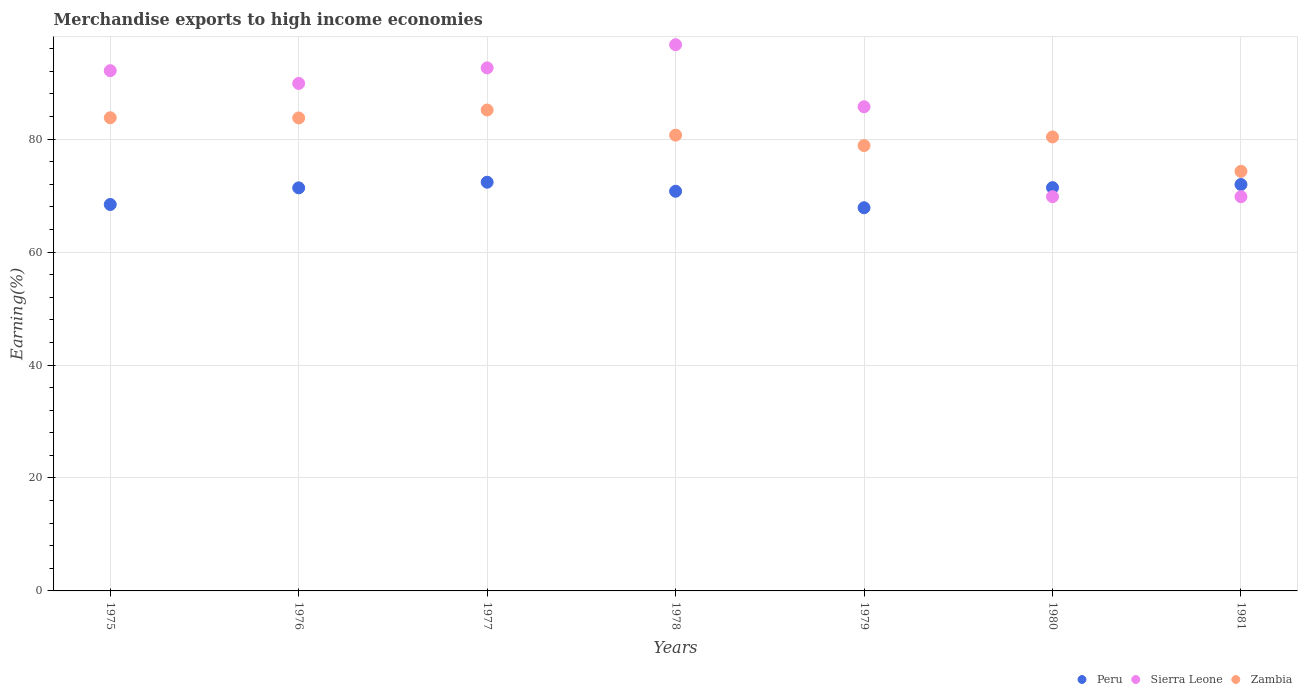How many different coloured dotlines are there?
Keep it short and to the point. 3. Is the number of dotlines equal to the number of legend labels?
Make the answer very short. Yes. What is the percentage of amount earned from merchandise exports in Peru in 1976?
Your answer should be compact. 71.38. Across all years, what is the maximum percentage of amount earned from merchandise exports in Sierra Leone?
Offer a very short reply. 96.72. Across all years, what is the minimum percentage of amount earned from merchandise exports in Zambia?
Provide a succinct answer. 74.3. In which year was the percentage of amount earned from merchandise exports in Peru maximum?
Give a very brief answer. 1977. In which year was the percentage of amount earned from merchandise exports in Sierra Leone minimum?
Keep it short and to the point. 1980. What is the total percentage of amount earned from merchandise exports in Sierra Leone in the graph?
Provide a short and direct response. 596.7. What is the difference between the percentage of amount earned from merchandise exports in Zambia in 1976 and that in 1978?
Give a very brief answer. 3.04. What is the difference between the percentage of amount earned from merchandise exports in Zambia in 1979 and the percentage of amount earned from merchandise exports in Sierra Leone in 1978?
Make the answer very short. -17.86. What is the average percentage of amount earned from merchandise exports in Zambia per year?
Offer a terse response. 81. In the year 1978, what is the difference between the percentage of amount earned from merchandise exports in Peru and percentage of amount earned from merchandise exports in Zambia?
Make the answer very short. -9.94. What is the ratio of the percentage of amount earned from merchandise exports in Sierra Leone in 1978 to that in 1981?
Keep it short and to the point. 1.39. What is the difference between the highest and the second highest percentage of amount earned from merchandise exports in Sierra Leone?
Offer a very short reply. 4.1. What is the difference between the highest and the lowest percentage of amount earned from merchandise exports in Peru?
Your answer should be compact. 4.52. Does the percentage of amount earned from merchandise exports in Sierra Leone monotonically increase over the years?
Ensure brevity in your answer.  No. Is the percentage of amount earned from merchandise exports in Peru strictly less than the percentage of amount earned from merchandise exports in Zambia over the years?
Ensure brevity in your answer.  Yes. How many dotlines are there?
Offer a very short reply. 3. How many years are there in the graph?
Offer a very short reply. 7. Does the graph contain any zero values?
Offer a very short reply. No. Does the graph contain grids?
Your answer should be very brief. Yes. Where does the legend appear in the graph?
Offer a very short reply. Bottom right. How many legend labels are there?
Your response must be concise. 3. What is the title of the graph?
Offer a terse response. Merchandise exports to high income economies. What is the label or title of the X-axis?
Give a very brief answer. Years. What is the label or title of the Y-axis?
Your answer should be very brief. Earning(%). What is the Earning(%) in Peru in 1975?
Offer a terse response. 68.43. What is the Earning(%) in Sierra Leone in 1975?
Your response must be concise. 92.13. What is the Earning(%) in Zambia in 1975?
Keep it short and to the point. 83.79. What is the Earning(%) in Peru in 1976?
Give a very brief answer. 71.38. What is the Earning(%) of Sierra Leone in 1976?
Your answer should be compact. 89.87. What is the Earning(%) in Zambia in 1976?
Keep it short and to the point. 83.76. What is the Earning(%) in Peru in 1977?
Offer a terse response. 72.38. What is the Earning(%) in Sierra Leone in 1977?
Provide a short and direct response. 92.62. What is the Earning(%) in Zambia in 1977?
Give a very brief answer. 85.16. What is the Earning(%) of Peru in 1978?
Offer a very short reply. 70.78. What is the Earning(%) of Sierra Leone in 1978?
Keep it short and to the point. 96.72. What is the Earning(%) in Zambia in 1978?
Offer a very short reply. 80.71. What is the Earning(%) in Peru in 1979?
Keep it short and to the point. 67.86. What is the Earning(%) of Sierra Leone in 1979?
Provide a succinct answer. 85.74. What is the Earning(%) in Zambia in 1979?
Your response must be concise. 78.87. What is the Earning(%) in Peru in 1980?
Your answer should be very brief. 71.42. What is the Earning(%) in Sierra Leone in 1980?
Make the answer very short. 69.81. What is the Earning(%) of Zambia in 1980?
Your answer should be very brief. 80.39. What is the Earning(%) of Peru in 1981?
Make the answer very short. 71.97. What is the Earning(%) of Sierra Leone in 1981?
Ensure brevity in your answer.  69.81. What is the Earning(%) of Zambia in 1981?
Keep it short and to the point. 74.3. Across all years, what is the maximum Earning(%) in Peru?
Your answer should be very brief. 72.38. Across all years, what is the maximum Earning(%) in Sierra Leone?
Offer a very short reply. 96.72. Across all years, what is the maximum Earning(%) in Zambia?
Ensure brevity in your answer.  85.16. Across all years, what is the minimum Earning(%) of Peru?
Give a very brief answer. 67.86. Across all years, what is the minimum Earning(%) in Sierra Leone?
Ensure brevity in your answer.  69.81. Across all years, what is the minimum Earning(%) of Zambia?
Your answer should be compact. 74.3. What is the total Earning(%) in Peru in the graph?
Your answer should be very brief. 494.2. What is the total Earning(%) of Sierra Leone in the graph?
Keep it short and to the point. 596.7. What is the total Earning(%) in Zambia in the graph?
Ensure brevity in your answer.  566.99. What is the difference between the Earning(%) in Peru in 1975 and that in 1976?
Your answer should be very brief. -2.95. What is the difference between the Earning(%) in Sierra Leone in 1975 and that in 1976?
Your answer should be compact. 2.26. What is the difference between the Earning(%) of Zambia in 1975 and that in 1976?
Give a very brief answer. 0.03. What is the difference between the Earning(%) in Peru in 1975 and that in 1977?
Offer a terse response. -3.95. What is the difference between the Earning(%) of Sierra Leone in 1975 and that in 1977?
Keep it short and to the point. -0.5. What is the difference between the Earning(%) in Zambia in 1975 and that in 1977?
Your response must be concise. -1.37. What is the difference between the Earning(%) of Peru in 1975 and that in 1978?
Make the answer very short. -2.35. What is the difference between the Earning(%) of Sierra Leone in 1975 and that in 1978?
Offer a very short reply. -4.6. What is the difference between the Earning(%) of Zambia in 1975 and that in 1978?
Ensure brevity in your answer.  3.08. What is the difference between the Earning(%) in Peru in 1975 and that in 1979?
Your answer should be very brief. 0.57. What is the difference between the Earning(%) in Sierra Leone in 1975 and that in 1979?
Make the answer very short. 6.39. What is the difference between the Earning(%) of Zambia in 1975 and that in 1979?
Offer a terse response. 4.92. What is the difference between the Earning(%) in Peru in 1975 and that in 1980?
Your response must be concise. -2.99. What is the difference between the Earning(%) in Sierra Leone in 1975 and that in 1980?
Your answer should be compact. 22.32. What is the difference between the Earning(%) of Zambia in 1975 and that in 1980?
Make the answer very short. 3.4. What is the difference between the Earning(%) in Peru in 1975 and that in 1981?
Provide a short and direct response. -3.54. What is the difference between the Earning(%) in Sierra Leone in 1975 and that in 1981?
Offer a very short reply. 22.32. What is the difference between the Earning(%) of Zambia in 1975 and that in 1981?
Your answer should be very brief. 9.49. What is the difference between the Earning(%) of Peru in 1976 and that in 1977?
Offer a very short reply. -1. What is the difference between the Earning(%) of Sierra Leone in 1976 and that in 1977?
Provide a short and direct response. -2.76. What is the difference between the Earning(%) in Zambia in 1976 and that in 1977?
Provide a succinct answer. -1.4. What is the difference between the Earning(%) in Peru in 1976 and that in 1978?
Make the answer very short. 0.6. What is the difference between the Earning(%) in Sierra Leone in 1976 and that in 1978?
Give a very brief answer. -6.86. What is the difference between the Earning(%) in Zambia in 1976 and that in 1978?
Make the answer very short. 3.04. What is the difference between the Earning(%) in Peru in 1976 and that in 1979?
Give a very brief answer. 3.52. What is the difference between the Earning(%) in Sierra Leone in 1976 and that in 1979?
Your answer should be compact. 4.13. What is the difference between the Earning(%) in Zambia in 1976 and that in 1979?
Ensure brevity in your answer.  4.89. What is the difference between the Earning(%) of Peru in 1976 and that in 1980?
Your response must be concise. -0.04. What is the difference between the Earning(%) in Sierra Leone in 1976 and that in 1980?
Keep it short and to the point. 20.06. What is the difference between the Earning(%) of Zambia in 1976 and that in 1980?
Provide a short and direct response. 3.37. What is the difference between the Earning(%) in Peru in 1976 and that in 1981?
Your answer should be compact. -0.59. What is the difference between the Earning(%) of Sierra Leone in 1976 and that in 1981?
Make the answer very short. 20.06. What is the difference between the Earning(%) in Zambia in 1976 and that in 1981?
Make the answer very short. 9.45. What is the difference between the Earning(%) of Peru in 1977 and that in 1978?
Provide a short and direct response. 1.6. What is the difference between the Earning(%) in Sierra Leone in 1977 and that in 1978?
Offer a very short reply. -4.1. What is the difference between the Earning(%) in Zambia in 1977 and that in 1978?
Your answer should be compact. 4.45. What is the difference between the Earning(%) in Peru in 1977 and that in 1979?
Ensure brevity in your answer.  4.52. What is the difference between the Earning(%) in Sierra Leone in 1977 and that in 1979?
Offer a very short reply. 6.89. What is the difference between the Earning(%) of Zambia in 1977 and that in 1979?
Provide a succinct answer. 6.29. What is the difference between the Earning(%) in Sierra Leone in 1977 and that in 1980?
Your answer should be compact. 22.81. What is the difference between the Earning(%) in Zambia in 1977 and that in 1980?
Your answer should be compact. 4.77. What is the difference between the Earning(%) of Peru in 1977 and that in 1981?
Ensure brevity in your answer.  0.41. What is the difference between the Earning(%) of Sierra Leone in 1977 and that in 1981?
Make the answer very short. 22.81. What is the difference between the Earning(%) of Zambia in 1977 and that in 1981?
Make the answer very short. 10.86. What is the difference between the Earning(%) in Peru in 1978 and that in 1979?
Offer a very short reply. 2.92. What is the difference between the Earning(%) in Sierra Leone in 1978 and that in 1979?
Offer a very short reply. 10.99. What is the difference between the Earning(%) in Zambia in 1978 and that in 1979?
Offer a very short reply. 1.85. What is the difference between the Earning(%) in Peru in 1978 and that in 1980?
Your answer should be very brief. -0.64. What is the difference between the Earning(%) in Sierra Leone in 1978 and that in 1980?
Keep it short and to the point. 26.91. What is the difference between the Earning(%) in Zambia in 1978 and that in 1980?
Your response must be concise. 0.32. What is the difference between the Earning(%) in Peru in 1978 and that in 1981?
Give a very brief answer. -1.19. What is the difference between the Earning(%) of Sierra Leone in 1978 and that in 1981?
Ensure brevity in your answer.  26.91. What is the difference between the Earning(%) of Zambia in 1978 and that in 1981?
Offer a terse response. 6.41. What is the difference between the Earning(%) of Peru in 1979 and that in 1980?
Your answer should be compact. -3.56. What is the difference between the Earning(%) in Sierra Leone in 1979 and that in 1980?
Ensure brevity in your answer.  15.93. What is the difference between the Earning(%) of Zambia in 1979 and that in 1980?
Give a very brief answer. -1.52. What is the difference between the Earning(%) of Peru in 1979 and that in 1981?
Your answer should be very brief. -4.11. What is the difference between the Earning(%) of Sierra Leone in 1979 and that in 1981?
Offer a terse response. 15.93. What is the difference between the Earning(%) in Zambia in 1979 and that in 1981?
Offer a terse response. 4.56. What is the difference between the Earning(%) in Peru in 1980 and that in 1981?
Give a very brief answer. -0.55. What is the difference between the Earning(%) in Sierra Leone in 1980 and that in 1981?
Ensure brevity in your answer.  -0. What is the difference between the Earning(%) in Zambia in 1980 and that in 1981?
Provide a succinct answer. 6.09. What is the difference between the Earning(%) in Peru in 1975 and the Earning(%) in Sierra Leone in 1976?
Give a very brief answer. -21.44. What is the difference between the Earning(%) in Peru in 1975 and the Earning(%) in Zambia in 1976?
Keep it short and to the point. -15.33. What is the difference between the Earning(%) of Sierra Leone in 1975 and the Earning(%) of Zambia in 1976?
Keep it short and to the point. 8.37. What is the difference between the Earning(%) of Peru in 1975 and the Earning(%) of Sierra Leone in 1977?
Make the answer very short. -24.19. What is the difference between the Earning(%) of Peru in 1975 and the Earning(%) of Zambia in 1977?
Your response must be concise. -16.73. What is the difference between the Earning(%) in Sierra Leone in 1975 and the Earning(%) in Zambia in 1977?
Your answer should be very brief. 6.97. What is the difference between the Earning(%) in Peru in 1975 and the Earning(%) in Sierra Leone in 1978?
Offer a very short reply. -28.29. What is the difference between the Earning(%) of Peru in 1975 and the Earning(%) of Zambia in 1978?
Offer a very short reply. -12.28. What is the difference between the Earning(%) of Sierra Leone in 1975 and the Earning(%) of Zambia in 1978?
Provide a short and direct response. 11.41. What is the difference between the Earning(%) of Peru in 1975 and the Earning(%) of Sierra Leone in 1979?
Your answer should be very brief. -17.31. What is the difference between the Earning(%) of Peru in 1975 and the Earning(%) of Zambia in 1979?
Ensure brevity in your answer.  -10.44. What is the difference between the Earning(%) in Sierra Leone in 1975 and the Earning(%) in Zambia in 1979?
Keep it short and to the point. 13.26. What is the difference between the Earning(%) in Peru in 1975 and the Earning(%) in Sierra Leone in 1980?
Offer a terse response. -1.38. What is the difference between the Earning(%) of Peru in 1975 and the Earning(%) of Zambia in 1980?
Your answer should be very brief. -11.96. What is the difference between the Earning(%) in Sierra Leone in 1975 and the Earning(%) in Zambia in 1980?
Provide a short and direct response. 11.74. What is the difference between the Earning(%) of Peru in 1975 and the Earning(%) of Sierra Leone in 1981?
Your response must be concise. -1.38. What is the difference between the Earning(%) of Peru in 1975 and the Earning(%) of Zambia in 1981?
Your answer should be very brief. -5.87. What is the difference between the Earning(%) of Sierra Leone in 1975 and the Earning(%) of Zambia in 1981?
Provide a short and direct response. 17.82. What is the difference between the Earning(%) of Peru in 1976 and the Earning(%) of Sierra Leone in 1977?
Offer a terse response. -21.25. What is the difference between the Earning(%) in Peru in 1976 and the Earning(%) in Zambia in 1977?
Your answer should be very brief. -13.79. What is the difference between the Earning(%) of Sierra Leone in 1976 and the Earning(%) of Zambia in 1977?
Give a very brief answer. 4.71. What is the difference between the Earning(%) in Peru in 1976 and the Earning(%) in Sierra Leone in 1978?
Provide a short and direct response. -25.35. What is the difference between the Earning(%) of Peru in 1976 and the Earning(%) of Zambia in 1978?
Keep it short and to the point. -9.34. What is the difference between the Earning(%) in Sierra Leone in 1976 and the Earning(%) in Zambia in 1978?
Provide a short and direct response. 9.15. What is the difference between the Earning(%) of Peru in 1976 and the Earning(%) of Sierra Leone in 1979?
Ensure brevity in your answer.  -14.36. What is the difference between the Earning(%) in Peru in 1976 and the Earning(%) in Zambia in 1979?
Your answer should be very brief. -7.49. What is the difference between the Earning(%) of Sierra Leone in 1976 and the Earning(%) of Zambia in 1979?
Your answer should be compact. 11. What is the difference between the Earning(%) in Peru in 1976 and the Earning(%) in Sierra Leone in 1980?
Offer a very short reply. 1.56. What is the difference between the Earning(%) of Peru in 1976 and the Earning(%) of Zambia in 1980?
Provide a succinct answer. -9.02. What is the difference between the Earning(%) of Sierra Leone in 1976 and the Earning(%) of Zambia in 1980?
Your answer should be compact. 9.48. What is the difference between the Earning(%) of Peru in 1976 and the Earning(%) of Sierra Leone in 1981?
Your answer should be very brief. 1.56. What is the difference between the Earning(%) of Peru in 1976 and the Earning(%) of Zambia in 1981?
Your response must be concise. -2.93. What is the difference between the Earning(%) of Sierra Leone in 1976 and the Earning(%) of Zambia in 1981?
Your answer should be very brief. 15.56. What is the difference between the Earning(%) of Peru in 1977 and the Earning(%) of Sierra Leone in 1978?
Your response must be concise. -24.35. What is the difference between the Earning(%) of Peru in 1977 and the Earning(%) of Zambia in 1978?
Keep it short and to the point. -8.34. What is the difference between the Earning(%) in Sierra Leone in 1977 and the Earning(%) in Zambia in 1978?
Keep it short and to the point. 11.91. What is the difference between the Earning(%) of Peru in 1977 and the Earning(%) of Sierra Leone in 1979?
Provide a succinct answer. -13.36. What is the difference between the Earning(%) in Peru in 1977 and the Earning(%) in Zambia in 1979?
Provide a short and direct response. -6.49. What is the difference between the Earning(%) in Sierra Leone in 1977 and the Earning(%) in Zambia in 1979?
Offer a terse response. 13.76. What is the difference between the Earning(%) in Peru in 1977 and the Earning(%) in Sierra Leone in 1980?
Make the answer very short. 2.57. What is the difference between the Earning(%) in Peru in 1977 and the Earning(%) in Zambia in 1980?
Provide a short and direct response. -8.02. What is the difference between the Earning(%) in Sierra Leone in 1977 and the Earning(%) in Zambia in 1980?
Give a very brief answer. 12.23. What is the difference between the Earning(%) in Peru in 1977 and the Earning(%) in Sierra Leone in 1981?
Your response must be concise. 2.57. What is the difference between the Earning(%) of Peru in 1977 and the Earning(%) of Zambia in 1981?
Your answer should be very brief. -1.93. What is the difference between the Earning(%) of Sierra Leone in 1977 and the Earning(%) of Zambia in 1981?
Your answer should be very brief. 18.32. What is the difference between the Earning(%) in Peru in 1978 and the Earning(%) in Sierra Leone in 1979?
Keep it short and to the point. -14.96. What is the difference between the Earning(%) in Peru in 1978 and the Earning(%) in Zambia in 1979?
Ensure brevity in your answer.  -8.09. What is the difference between the Earning(%) in Sierra Leone in 1978 and the Earning(%) in Zambia in 1979?
Your answer should be compact. 17.86. What is the difference between the Earning(%) in Peru in 1978 and the Earning(%) in Sierra Leone in 1980?
Your response must be concise. 0.97. What is the difference between the Earning(%) in Peru in 1978 and the Earning(%) in Zambia in 1980?
Give a very brief answer. -9.62. What is the difference between the Earning(%) of Sierra Leone in 1978 and the Earning(%) of Zambia in 1980?
Your answer should be very brief. 16.33. What is the difference between the Earning(%) of Peru in 1978 and the Earning(%) of Sierra Leone in 1981?
Make the answer very short. 0.97. What is the difference between the Earning(%) in Peru in 1978 and the Earning(%) in Zambia in 1981?
Make the answer very short. -3.53. What is the difference between the Earning(%) in Sierra Leone in 1978 and the Earning(%) in Zambia in 1981?
Provide a succinct answer. 22.42. What is the difference between the Earning(%) of Peru in 1979 and the Earning(%) of Sierra Leone in 1980?
Provide a succinct answer. -1.95. What is the difference between the Earning(%) of Peru in 1979 and the Earning(%) of Zambia in 1980?
Ensure brevity in your answer.  -12.53. What is the difference between the Earning(%) in Sierra Leone in 1979 and the Earning(%) in Zambia in 1980?
Provide a short and direct response. 5.35. What is the difference between the Earning(%) in Peru in 1979 and the Earning(%) in Sierra Leone in 1981?
Your answer should be compact. -1.95. What is the difference between the Earning(%) of Peru in 1979 and the Earning(%) of Zambia in 1981?
Offer a very short reply. -6.45. What is the difference between the Earning(%) in Sierra Leone in 1979 and the Earning(%) in Zambia in 1981?
Give a very brief answer. 11.43. What is the difference between the Earning(%) in Peru in 1980 and the Earning(%) in Sierra Leone in 1981?
Give a very brief answer. 1.61. What is the difference between the Earning(%) of Peru in 1980 and the Earning(%) of Zambia in 1981?
Provide a succinct answer. -2.89. What is the difference between the Earning(%) in Sierra Leone in 1980 and the Earning(%) in Zambia in 1981?
Your answer should be compact. -4.49. What is the average Earning(%) in Peru per year?
Provide a short and direct response. 70.6. What is the average Earning(%) of Sierra Leone per year?
Keep it short and to the point. 85.24. What is the average Earning(%) in Zambia per year?
Keep it short and to the point. 81. In the year 1975, what is the difference between the Earning(%) of Peru and Earning(%) of Sierra Leone?
Your answer should be compact. -23.7. In the year 1975, what is the difference between the Earning(%) of Peru and Earning(%) of Zambia?
Offer a terse response. -15.36. In the year 1975, what is the difference between the Earning(%) in Sierra Leone and Earning(%) in Zambia?
Your answer should be compact. 8.34. In the year 1976, what is the difference between the Earning(%) in Peru and Earning(%) in Sierra Leone?
Ensure brevity in your answer.  -18.49. In the year 1976, what is the difference between the Earning(%) in Peru and Earning(%) in Zambia?
Keep it short and to the point. -12.38. In the year 1976, what is the difference between the Earning(%) in Sierra Leone and Earning(%) in Zambia?
Keep it short and to the point. 6.11. In the year 1977, what is the difference between the Earning(%) in Peru and Earning(%) in Sierra Leone?
Ensure brevity in your answer.  -20.25. In the year 1977, what is the difference between the Earning(%) of Peru and Earning(%) of Zambia?
Ensure brevity in your answer.  -12.79. In the year 1977, what is the difference between the Earning(%) in Sierra Leone and Earning(%) in Zambia?
Your answer should be very brief. 7.46. In the year 1978, what is the difference between the Earning(%) in Peru and Earning(%) in Sierra Leone?
Ensure brevity in your answer.  -25.95. In the year 1978, what is the difference between the Earning(%) of Peru and Earning(%) of Zambia?
Provide a short and direct response. -9.94. In the year 1978, what is the difference between the Earning(%) of Sierra Leone and Earning(%) of Zambia?
Ensure brevity in your answer.  16.01. In the year 1979, what is the difference between the Earning(%) of Peru and Earning(%) of Sierra Leone?
Provide a succinct answer. -17.88. In the year 1979, what is the difference between the Earning(%) of Peru and Earning(%) of Zambia?
Provide a short and direct response. -11.01. In the year 1979, what is the difference between the Earning(%) in Sierra Leone and Earning(%) in Zambia?
Provide a succinct answer. 6.87. In the year 1980, what is the difference between the Earning(%) in Peru and Earning(%) in Sierra Leone?
Your answer should be very brief. 1.61. In the year 1980, what is the difference between the Earning(%) of Peru and Earning(%) of Zambia?
Your answer should be very brief. -8.97. In the year 1980, what is the difference between the Earning(%) of Sierra Leone and Earning(%) of Zambia?
Your answer should be compact. -10.58. In the year 1981, what is the difference between the Earning(%) in Peru and Earning(%) in Sierra Leone?
Your answer should be compact. 2.16. In the year 1981, what is the difference between the Earning(%) in Peru and Earning(%) in Zambia?
Your answer should be compact. -2.33. In the year 1981, what is the difference between the Earning(%) of Sierra Leone and Earning(%) of Zambia?
Provide a succinct answer. -4.49. What is the ratio of the Earning(%) of Peru in 1975 to that in 1976?
Keep it short and to the point. 0.96. What is the ratio of the Earning(%) of Sierra Leone in 1975 to that in 1976?
Offer a terse response. 1.03. What is the ratio of the Earning(%) in Peru in 1975 to that in 1977?
Ensure brevity in your answer.  0.95. What is the ratio of the Earning(%) of Zambia in 1975 to that in 1977?
Your response must be concise. 0.98. What is the ratio of the Earning(%) of Peru in 1975 to that in 1978?
Your response must be concise. 0.97. What is the ratio of the Earning(%) of Sierra Leone in 1975 to that in 1978?
Provide a succinct answer. 0.95. What is the ratio of the Earning(%) in Zambia in 1975 to that in 1978?
Make the answer very short. 1.04. What is the ratio of the Earning(%) of Peru in 1975 to that in 1979?
Provide a succinct answer. 1.01. What is the ratio of the Earning(%) of Sierra Leone in 1975 to that in 1979?
Your answer should be very brief. 1.07. What is the ratio of the Earning(%) of Zambia in 1975 to that in 1979?
Give a very brief answer. 1.06. What is the ratio of the Earning(%) of Peru in 1975 to that in 1980?
Offer a very short reply. 0.96. What is the ratio of the Earning(%) in Sierra Leone in 1975 to that in 1980?
Offer a terse response. 1.32. What is the ratio of the Earning(%) of Zambia in 1975 to that in 1980?
Your answer should be compact. 1.04. What is the ratio of the Earning(%) in Peru in 1975 to that in 1981?
Offer a terse response. 0.95. What is the ratio of the Earning(%) in Sierra Leone in 1975 to that in 1981?
Provide a short and direct response. 1.32. What is the ratio of the Earning(%) of Zambia in 1975 to that in 1981?
Make the answer very short. 1.13. What is the ratio of the Earning(%) in Peru in 1976 to that in 1977?
Provide a short and direct response. 0.99. What is the ratio of the Earning(%) in Sierra Leone in 1976 to that in 1977?
Provide a short and direct response. 0.97. What is the ratio of the Earning(%) in Zambia in 1976 to that in 1977?
Provide a succinct answer. 0.98. What is the ratio of the Earning(%) in Peru in 1976 to that in 1978?
Offer a terse response. 1.01. What is the ratio of the Earning(%) in Sierra Leone in 1976 to that in 1978?
Offer a very short reply. 0.93. What is the ratio of the Earning(%) of Zambia in 1976 to that in 1978?
Provide a short and direct response. 1.04. What is the ratio of the Earning(%) of Peru in 1976 to that in 1979?
Make the answer very short. 1.05. What is the ratio of the Earning(%) of Sierra Leone in 1976 to that in 1979?
Your answer should be very brief. 1.05. What is the ratio of the Earning(%) in Zambia in 1976 to that in 1979?
Provide a short and direct response. 1.06. What is the ratio of the Earning(%) of Peru in 1976 to that in 1980?
Your answer should be very brief. 1. What is the ratio of the Earning(%) in Sierra Leone in 1976 to that in 1980?
Offer a terse response. 1.29. What is the ratio of the Earning(%) in Zambia in 1976 to that in 1980?
Offer a very short reply. 1.04. What is the ratio of the Earning(%) in Peru in 1976 to that in 1981?
Your response must be concise. 0.99. What is the ratio of the Earning(%) of Sierra Leone in 1976 to that in 1981?
Offer a terse response. 1.29. What is the ratio of the Earning(%) in Zambia in 1976 to that in 1981?
Offer a terse response. 1.13. What is the ratio of the Earning(%) in Peru in 1977 to that in 1978?
Provide a short and direct response. 1.02. What is the ratio of the Earning(%) of Sierra Leone in 1977 to that in 1978?
Your answer should be very brief. 0.96. What is the ratio of the Earning(%) in Zambia in 1977 to that in 1978?
Provide a short and direct response. 1.06. What is the ratio of the Earning(%) in Peru in 1977 to that in 1979?
Your response must be concise. 1.07. What is the ratio of the Earning(%) in Sierra Leone in 1977 to that in 1979?
Your answer should be compact. 1.08. What is the ratio of the Earning(%) of Zambia in 1977 to that in 1979?
Your answer should be very brief. 1.08. What is the ratio of the Earning(%) in Peru in 1977 to that in 1980?
Offer a very short reply. 1.01. What is the ratio of the Earning(%) of Sierra Leone in 1977 to that in 1980?
Your answer should be compact. 1.33. What is the ratio of the Earning(%) of Zambia in 1977 to that in 1980?
Give a very brief answer. 1.06. What is the ratio of the Earning(%) in Peru in 1977 to that in 1981?
Give a very brief answer. 1.01. What is the ratio of the Earning(%) of Sierra Leone in 1977 to that in 1981?
Your answer should be compact. 1.33. What is the ratio of the Earning(%) of Zambia in 1977 to that in 1981?
Keep it short and to the point. 1.15. What is the ratio of the Earning(%) of Peru in 1978 to that in 1979?
Provide a succinct answer. 1.04. What is the ratio of the Earning(%) in Sierra Leone in 1978 to that in 1979?
Provide a succinct answer. 1.13. What is the ratio of the Earning(%) in Zambia in 1978 to that in 1979?
Ensure brevity in your answer.  1.02. What is the ratio of the Earning(%) in Sierra Leone in 1978 to that in 1980?
Offer a very short reply. 1.39. What is the ratio of the Earning(%) of Zambia in 1978 to that in 1980?
Give a very brief answer. 1. What is the ratio of the Earning(%) in Peru in 1978 to that in 1981?
Make the answer very short. 0.98. What is the ratio of the Earning(%) of Sierra Leone in 1978 to that in 1981?
Give a very brief answer. 1.39. What is the ratio of the Earning(%) in Zambia in 1978 to that in 1981?
Your response must be concise. 1.09. What is the ratio of the Earning(%) in Peru in 1979 to that in 1980?
Give a very brief answer. 0.95. What is the ratio of the Earning(%) of Sierra Leone in 1979 to that in 1980?
Your answer should be compact. 1.23. What is the ratio of the Earning(%) of Zambia in 1979 to that in 1980?
Your answer should be very brief. 0.98. What is the ratio of the Earning(%) of Peru in 1979 to that in 1981?
Make the answer very short. 0.94. What is the ratio of the Earning(%) in Sierra Leone in 1979 to that in 1981?
Your answer should be compact. 1.23. What is the ratio of the Earning(%) of Zambia in 1979 to that in 1981?
Provide a succinct answer. 1.06. What is the ratio of the Earning(%) of Zambia in 1980 to that in 1981?
Offer a terse response. 1.08. What is the difference between the highest and the second highest Earning(%) of Peru?
Your answer should be very brief. 0.41. What is the difference between the highest and the second highest Earning(%) in Sierra Leone?
Your answer should be compact. 4.1. What is the difference between the highest and the second highest Earning(%) in Zambia?
Make the answer very short. 1.37. What is the difference between the highest and the lowest Earning(%) in Peru?
Make the answer very short. 4.52. What is the difference between the highest and the lowest Earning(%) of Sierra Leone?
Your answer should be compact. 26.91. What is the difference between the highest and the lowest Earning(%) of Zambia?
Offer a terse response. 10.86. 